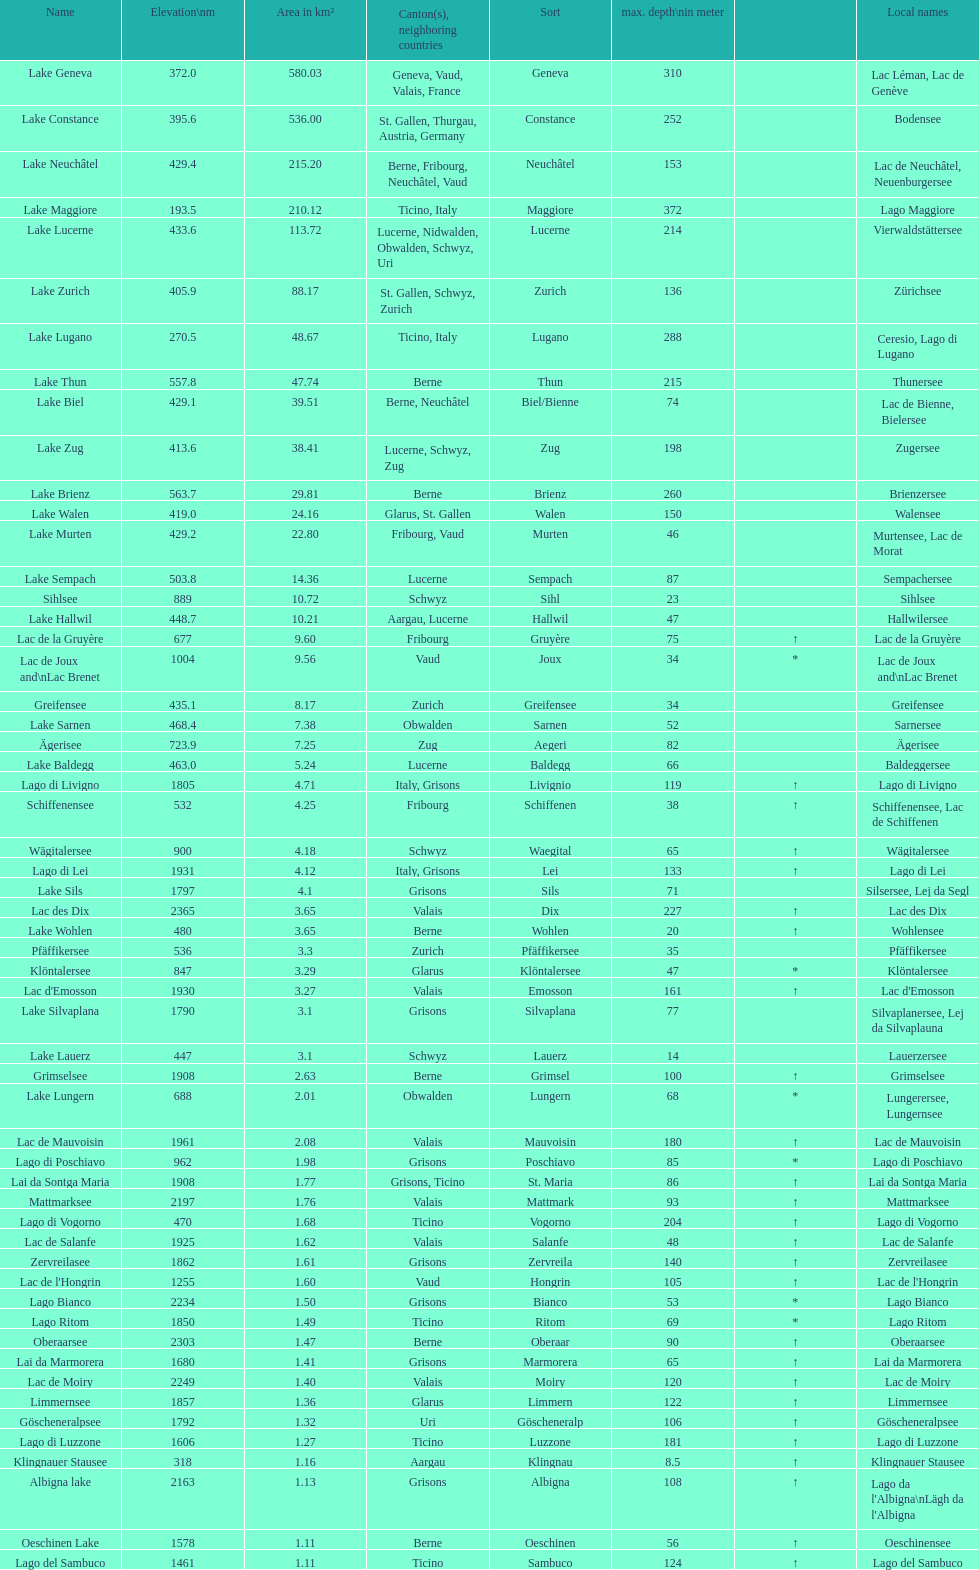Name the largest lake Lake Geneva. 